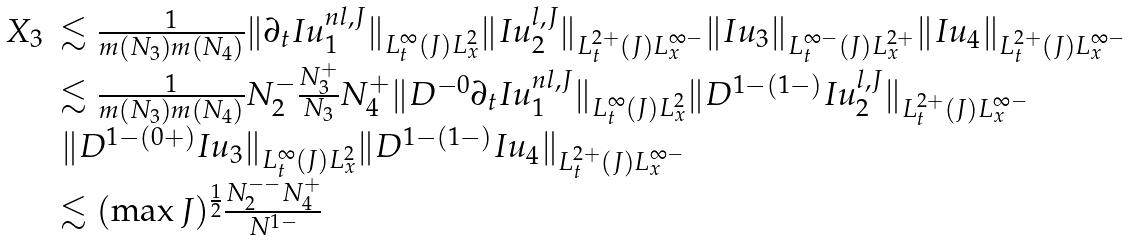<formula> <loc_0><loc_0><loc_500><loc_500>\begin{array} { l l } X _ { 3 } & \lesssim \frac { 1 } { m ( N _ { 3 } ) m ( N _ { 4 } ) } \| \partial _ { t } I u ^ { n l , J } _ { 1 } \| _ { L _ { t } ^ { \infty } ( J ) L _ { x } ^ { 2 } } \| I u _ { 2 } ^ { l , J } \| _ { L _ { t } ^ { 2 + } ( J ) L _ { x } ^ { \infty - } } \| I u _ { 3 } \| _ { L _ { t } ^ { \infty - } ( J ) L _ { x } ^ { 2 + } } \| I u _ { 4 } \| _ { L _ { t } ^ { 2 + } ( J ) L _ { x } ^ { \infty - } } \\ & \lesssim \frac { 1 } { m ( N _ { 3 } ) m ( N _ { 4 } ) } N _ { 2 } ^ { - } \frac { N _ { 3 } ^ { + } } { N _ { 3 } } N _ { 4 } ^ { + } \| D ^ { - 0 } \partial _ { t } I u _ { 1 } ^ { n l , J } \| _ { L _ { t } ^ { \infty } ( J ) L _ { x } ^ { 2 } } \| D ^ { 1 - ( 1 - ) } I u _ { 2 } ^ { l , J } \| _ { L _ { t } ^ { 2 + } ( J ) L _ { x } ^ { \infty - } } \\ & \| D ^ { 1 - ( 0 + ) } I u _ { 3 } \| _ { L _ { t } ^ { \infty } ( J ) L _ { x } ^ { 2 } } \| D ^ { 1 - ( 1 - ) } I u _ { 4 } \| _ { L _ { t } ^ { 2 + } ( J ) L _ { x } ^ { \infty - } } \\ & \lesssim ( \max J ) ^ { \frac { 1 } { 2 } } \frac { N _ { 2 } ^ { - - } N _ { 4 } ^ { + } } { N ^ { 1 - } } \end{array}</formula> 